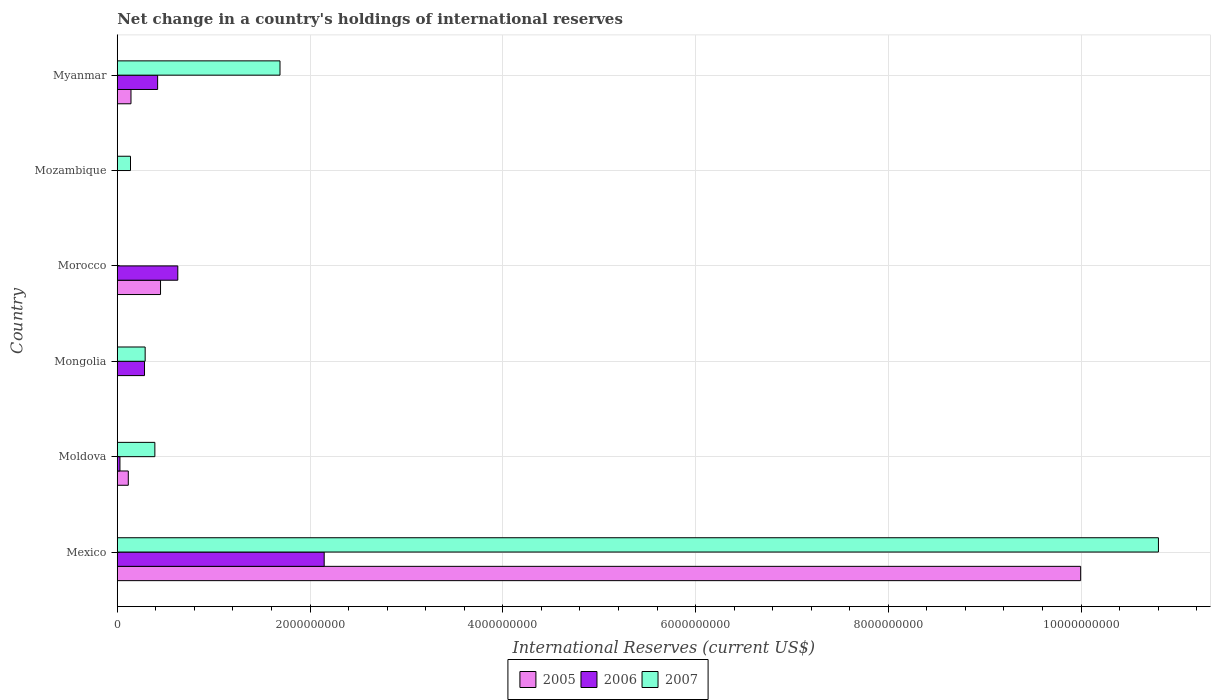Are the number of bars per tick equal to the number of legend labels?
Make the answer very short. No. Are the number of bars on each tick of the Y-axis equal?
Your response must be concise. No. How many bars are there on the 4th tick from the bottom?
Keep it short and to the point. 2. What is the label of the 5th group of bars from the top?
Provide a short and direct response. Moldova. In how many cases, is the number of bars for a given country not equal to the number of legend labels?
Offer a very short reply. 3. What is the international reserves in 2005 in Myanmar?
Provide a short and direct response. 1.42e+08. Across all countries, what is the maximum international reserves in 2007?
Keep it short and to the point. 1.08e+1. Across all countries, what is the minimum international reserves in 2005?
Ensure brevity in your answer.  0. What is the total international reserves in 2006 in the graph?
Give a very brief answer. 3.50e+09. What is the difference between the international reserves in 2006 in Mexico and that in Myanmar?
Offer a terse response. 1.73e+09. What is the difference between the international reserves in 2007 in Moldova and the international reserves in 2005 in Mongolia?
Your response must be concise. 3.90e+08. What is the average international reserves in 2006 per country?
Your response must be concise. 5.84e+08. What is the difference between the international reserves in 2007 and international reserves in 2005 in Moldova?
Your answer should be very brief. 2.76e+08. In how many countries, is the international reserves in 2006 greater than 7200000000 US$?
Give a very brief answer. 0. What is the ratio of the international reserves in 2007 in Moldova to that in Mongolia?
Your answer should be compact. 1.35. Is the difference between the international reserves in 2007 in Mexico and Myanmar greater than the difference between the international reserves in 2005 in Mexico and Myanmar?
Ensure brevity in your answer.  No. What is the difference between the highest and the second highest international reserves in 2006?
Provide a short and direct response. 1.52e+09. What is the difference between the highest and the lowest international reserves in 2007?
Ensure brevity in your answer.  1.08e+1. In how many countries, is the international reserves in 2005 greater than the average international reserves in 2005 taken over all countries?
Your answer should be very brief. 1. Are the values on the major ticks of X-axis written in scientific E-notation?
Provide a succinct answer. No. Where does the legend appear in the graph?
Your answer should be very brief. Bottom center. What is the title of the graph?
Keep it short and to the point. Net change in a country's holdings of international reserves. Does "2013" appear as one of the legend labels in the graph?
Keep it short and to the point. No. What is the label or title of the X-axis?
Your response must be concise. International Reserves (current US$). What is the label or title of the Y-axis?
Your response must be concise. Country. What is the International Reserves (current US$) in 2005 in Mexico?
Your response must be concise. 1.00e+1. What is the International Reserves (current US$) in 2006 in Mexico?
Your answer should be very brief. 2.15e+09. What is the International Reserves (current US$) of 2007 in Mexico?
Your answer should be compact. 1.08e+1. What is the International Reserves (current US$) of 2005 in Moldova?
Your answer should be compact. 1.14e+08. What is the International Reserves (current US$) in 2006 in Moldova?
Give a very brief answer. 2.75e+07. What is the International Reserves (current US$) of 2007 in Moldova?
Your response must be concise. 3.90e+08. What is the International Reserves (current US$) in 2006 in Mongolia?
Keep it short and to the point. 2.83e+08. What is the International Reserves (current US$) of 2007 in Mongolia?
Offer a very short reply. 2.89e+08. What is the International Reserves (current US$) of 2005 in Morocco?
Provide a short and direct response. 4.49e+08. What is the International Reserves (current US$) of 2006 in Morocco?
Your answer should be very brief. 6.28e+08. What is the International Reserves (current US$) of 2007 in Morocco?
Ensure brevity in your answer.  0. What is the International Reserves (current US$) in 2007 in Mozambique?
Your answer should be compact. 1.37e+08. What is the International Reserves (current US$) in 2005 in Myanmar?
Provide a succinct answer. 1.42e+08. What is the International Reserves (current US$) of 2006 in Myanmar?
Make the answer very short. 4.19e+08. What is the International Reserves (current US$) of 2007 in Myanmar?
Ensure brevity in your answer.  1.69e+09. Across all countries, what is the maximum International Reserves (current US$) of 2005?
Give a very brief answer. 1.00e+1. Across all countries, what is the maximum International Reserves (current US$) of 2006?
Make the answer very short. 2.15e+09. Across all countries, what is the maximum International Reserves (current US$) in 2007?
Keep it short and to the point. 1.08e+1. Across all countries, what is the minimum International Reserves (current US$) in 2005?
Make the answer very short. 0. What is the total International Reserves (current US$) of 2005 in the graph?
Your response must be concise. 1.07e+1. What is the total International Reserves (current US$) of 2006 in the graph?
Offer a terse response. 3.50e+09. What is the total International Reserves (current US$) of 2007 in the graph?
Your answer should be very brief. 1.33e+1. What is the difference between the International Reserves (current US$) of 2005 in Mexico and that in Moldova?
Offer a very short reply. 9.88e+09. What is the difference between the International Reserves (current US$) of 2006 in Mexico and that in Moldova?
Offer a terse response. 2.12e+09. What is the difference between the International Reserves (current US$) in 2007 in Mexico and that in Moldova?
Offer a very short reply. 1.04e+1. What is the difference between the International Reserves (current US$) of 2006 in Mexico and that in Mongolia?
Your response must be concise. 1.86e+09. What is the difference between the International Reserves (current US$) of 2007 in Mexico and that in Mongolia?
Provide a short and direct response. 1.05e+1. What is the difference between the International Reserves (current US$) in 2005 in Mexico and that in Morocco?
Ensure brevity in your answer.  9.55e+09. What is the difference between the International Reserves (current US$) in 2006 in Mexico and that in Morocco?
Offer a very short reply. 1.52e+09. What is the difference between the International Reserves (current US$) in 2007 in Mexico and that in Mozambique?
Your response must be concise. 1.07e+1. What is the difference between the International Reserves (current US$) in 2005 in Mexico and that in Myanmar?
Give a very brief answer. 9.85e+09. What is the difference between the International Reserves (current US$) of 2006 in Mexico and that in Myanmar?
Keep it short and to the point. 1.73e+09. What is the difference between the International Reserves (current US$) in 2007 in Mexico and that in Myanmar?
Offer a very short reply. 9.11e+09. What is the difference between the International Reserves (current US$) in 2006 in Moldova and that in Mongolia?
Provide a short and direct response. -2.55e+08. What is the difference between the International Reserves (current US$) of 2007 in Moldova and that in Mongolia?
Keep it short and to the point. 1.01e+08. What is the difference between the International Reserves (current US$) of 2005 in Moldova and that in Morocco?
Provide a short and direct response. -3.35e+08. What is the difference between the International Reserves (current US$) of 2006 in Moldova and that in Morocco?
Offer a terse response. -6.00e+08. What is the difference between the International Reserves (current US$) in 2007 in Moldova and that in Mozambique?
Ensure brevity in your answer.  2.53e+08. What is the difference between the International Reserves (current US$) in 2005 in Moldova and that in Myanmar?
Provide a succinct answer. -2.79e+07. What is the difference between the International Reserves (current US$) in 2006 in Moldova and that in Myanmar?
Offer a very short reply. -3.91e+08. What is the difference between the International Reserves (current US$) of 2007 in Moldova and that in Myanmar?
Offer a very short reply. -1.30e+09. What is the difference between the International Reserves (current US$) in 2006 in Mongolia and that in Morocco?
Your answer should be very brief. -3.45e+08. What is the difference between the International Reserves (current US$) in 2007 in Mongolia and that in Mozambique?
Make the answer very short. 1.52e+08. What is the difference between the International Reserves (current US$) in 2006 in Mongolia and that in Myanmar?
Make the answer very short. -1.36e+08. What is the difference between the International Reserves (current US$) in 2007 in Mongolia and that in Myanmar?
Provide a succinct answer. -1.40e+09. What is the difference between the International Reserves (current US$) of 2005 in Morocco and that in Myanmar?
Offer a very short reply. 3.07e+08. What is the difference between the International Reserves (current US$) of 2006 in Morocco and that in Myanmar?
Your answer should be compact. 2.09e+08. What is the difference between the International Reserves (current US$) in 2007 in Mozambique and that in Myanmar?
Offer a terse response. -1.55e+09. What is the difference between the International Reserves (current US$) in 2005 in Mexico and the International Reserves (current US$) in 2006 in Moldova?
Offer a terse response. 9.97e+09. What is the difference between the International Reserves (current US$) in 2005 in Mexico and the International Reserves (current US$) in 2007 in Moldova?
Give a very brief answer. 9.61e+09. What is the difference between the International Reserves (current US$) of 2006 in Mexico and the International Reserves (current US$) of 2007 in Moldova?
Your answer should be compact. 1.76e+09. What is the difference between the International Reserves (current US$) in 2005 in Mexico and the International Reserves (current US$) in 2006 in Mongolia?
Provide a succinct answer. 9.71e+09. What is the difference between the International Reserves (current US$) of 2005 in Mexico and the International Reserves (current US$) of 2007 in Mongolia?
Your answer should be compact. 9.71e+09. What is the difference between the International Reserves (current US$) in 2006 in Mexico and the International Reserves (current US$) in 2007 in Mongolia?
Keep it short and to the point. 1.86e+09. What is the difference between the International Reserves (current US$) in 2005 in Mexico and the International Reserves (current US$) in 2006 in Morocco?
Keep it short and to the point. 9.37e+09. What is the difference between the International Reserves (current US$) in 2005 in Mexico and the International Reserves (current US$) in 2007 in Mozambique?
Your answer should be very brief. 9.86e+09. What is the difference between the International Reserves (current US$) in 2006 in Mexico and the International Reserves (current US$) in 2007 in Mozambique?
Your answer should be very brief. 2.01e+09. What is the difference between the International Reserves (current US$) in 2005 in Mexico and the International Reserves (current US$) in 2006 in Myanmar?
Give a very brief answer. 9.58e+09. What is the difference between the International Reserves (current US$) of 2005 in Mexico and the International Reserves (current US$) of 2007 in Myanmar?
Your response must be concise. 8.31e+09. What is the difference between the International Reserves (current US$) of 2006 in Mexico and the International Reserves (current US$) of 2007 in Myanmar?
Make the answer very short. 4.58e+08. What is the difference between the International Reserves (current US$) of 2005 in Moldova and the International Reserves (current US$) of 2006 in Mongolia?
Give a very brief answer. -1.68e+08. What is the difference between the International Reserves (current US$) in 2005 in Moldova and the International Reserves (current US$) in 2007 in Mongolia?
Your answer should be very brief. -1.75e+08. What is the difference between the International Reserves (current US$) of 2006 in Moldova and the International Reserves (current US$) of 2007 in Mongolia?
Ensure brevity in your answer.  -2.62e+08. What is the difference between the International Reserves (current US$) of 2005 in Moldova and the International Reserves (current US$) of 2006 in Morocco?
Provide a succinct answer. -5.14e+08. What is the difference between the International Reserves (current US$) in 2005 in Moldova and the International Reserves (current US$) in 2007 in Mozambique?
Your answer should be compact. -2.29e+07. What is the difference between the International Reserves (current US$) of 2006 in Moldova and the International Reserves (current US$) of 2007 in Mozambique?
Your answer should be very brief. -1.10e+08. What is the difference between the International Reserves (current US$) in 2005 in Moldova and the International Reserves (current US$) in 2006 in Myanmar?
Offer a very short reply. -3.04e+08. What is the difference between the International Reserves (current US$) of 2005 in Moldova and the International Reserves (current US$) of 2007 in Myanmar?
Your response must be concise. -1.57e+09. What is the difference between the International Reserves (current US$) in 2006 in Moldova and the International Reserves (current US$) in 2007 in Myanmar?
Offer a very short reply. -1.66e+09. What is the difference between the International Reserves (current US$) of 2006 in Mongolia and the International Reserves (current US$) of 2007 in Mozambique?
Offer a very short reply. 1.45e+08. What is the difference between the International Reserves (current US$) in 2006 in Mongolia and the International Reserves (current US$) in 2007 in Myanmar?
Provide a short and direct response. -1.41e+09. What is the difference between the International Reserves (current US$) of 2005 in Morocco and the International Reserves (current US$) of 2007 in Mozambique?
Keep it short and to the point. 3.12e+08. What is the difference between the International Reserves (current US$) in 2006 in Morocco and the International Reserves (current US$) in 2007 in Mozambique?
Keep it short and to the point. 4.91e+08. What is the difference between the International Reserves (current US$) of 2005 in Morocco and the International Reserves (current US$) of 2006 in Myanmar?
Provide a short and direct response. 3.01e+07. What is the difference between the International Reserves (current US$) in 2005 in Morocco and the International Reserves (current US$) in 2007 in Myanmar?
Offer a terse response. -1.24e+09. What is the difference between the International Reserves (current US$) of 2006 in Morocco and the International Reserves (current US$) of 2007 in Myanmar?
Your response must be concise. -1.06e+09. What is the average International Reserves (current US$) of 2005 per country?
Offer a terse response. 1.78e+09. What is the average International Reserves (current US$) in 2006 per country?
Your response must be concise. 5.84e+08. What is the average International Reserves (current US$) of 2007 per country?
Your answer should be very brief. 2.22e+09. What is the difference between the International Reserves (current US$) in 2005 and International Reserves (current US$) in 2006 in Mexico?
Ensure brevity in your answer.  7.85e+09. What is the difference between the International Reserves (current US$) of 2005 and International Reserves (current US$) of 2007 in Mexico?
Provide a short and direct response. -8.07e+08. What is the difference between the International Reserves (current US$) of 2006 and International Reserves (current US$) of 2007 in Mexico?
Your answer should be compact. -8.66e+09. What is the difference between the International Reserves (current US$) of 2005 and International Reserves (current US$) of 2006 in Moldova?
Your answer should be very brief. 8.67e+07. What is the difference between the International Reserves (current US$) of 2005 and International Reserves (current US$) of 2007 in Moldova?
Make the answer very short. -2.76e+08. What is the difference between the International Reserves (current US$) of 2006 and International Reserves (current US$) of 2007 in Moldova?
Your response must be concise. -3.62e+08. What is the difference between the International Reserves (current US$) of 2006 and International Reserves (current US$) of 2007 in Mongolia?
Your response must be concise. -6.62e+06. What is the difference between the International Reserves (current US$) of 2005 and International Reserves (current US$) of 2006 in Morocco?
Offer a terse response. -1.79e+08. What is the difference between the International Reserves (current US$) in 2005 and International Reserves (current US$) in 2006 in Myanmar?
Your answer should be compact. -2.77e+08. What is the difference between the International Reserves (current US$) of 2005 and International Reserves (current US$) of 2007 in Myanmar?
Offer a terse response. -1.55e+09. What is the difference between the International Reserves (current US$) in 2006 and International Reserves (current US$) in 2007 in Myanmar?
Ensure brevity in your answer.  -1.27e+09. What is the ratio of the International Reserves (current US$) of 2005 in Mexico to that in Moldova?
Your answer should be compact. 87.52. What is the ratio of the International Reserves (current US$) in 2006 in Mexico to that in Moldova?
Ensure brevity in your answer.  78.11. What is the ratio of the International Reserves (current US$) in 2007 in Mexico to that in Moldova?
Keep it short and to the point. 27.7. What is the ratio of the International Reserves (current US$) of 2006 in Mexico to that in Mongolia?
Make the answer very short. 7.6. What is the ratio of the International Reserves (current US$) in 2007 in Mexico to that in Mongolia?
Your answer should be very brief. 37.36. What is the ratio of the International Reserves (current US$) in 2005 in Mexico to that in Morocco?
Give a very brief answer. 22.28. What is the ratio of the International Reserves (current US$) of 2006 in Mexico to that in Morocco?
Make the answer very short. 3.42. What is the ratio of the International Reserves (current US$) of 2007 in Mexico to that in Mozambique?
Your answer should be very brief. 78.79. What is the ratio of the International Reserves (current US$) in 2005 in Mexico to that in Myanmar?
Give a very brief answer. 70.34. What is the ratio of the International Reserves (current US$) of 2006 in Mexico to that in Myanmar?
Give a very brief answer. 5.13. What is the ratio of the International Reserves (current US$) of 2007 in Mexico to that in Myanmar?
Provide a short and direct response. 6.4. What is the ratio of the International Reserves (current US$) in 2006 in Moldova to that in Mongolia?
Offer a very short reply. 0.1. What is the ratio of the International Reserves (current US$) of 2007 in Moldova to that in Mongolia?
Provide a short and direct response. 1.35. What is the ratio of the International Reserves (current US$) of 2005 in Moldova to that in Morocco?
Provide a succinct answer. 0.25. What is the ratio of the International Reserves (current US$) in 2006 in Moldova to that in Morocco?
Your response must be concise. 0.04. What is the ratio of the International Reserves (current US$) of 2007 in Moldova to that in Mozambique?
Offer a very short reply. 2.84. What is the ratio of the International Reserves (current US$) in 2005 in Moldova to that in Myanmar?
Give a very brief answer. 0.8. What is the ratio of the International Reserves (current US$) in 2006 in Moldova to that in Myanmar?
Make the answer very short. 0.07. What is the ratio of the International Reserves (current US$) of 2007 in Moldova to that in Myanmar?
Keep it short and to the point. 0.23. What is the ratio of the International Reserves (current US$) in 2006 in Mongolia to that in Morocco?
Your answer should be compact. 0.45. What is the ratio of the International Reserves (current US$) in 2007 in Mongolia to that in Mozambique?
Offer a very short reply. 2.11. What is the ratio of the International Reserves (current US$) of 2006 in Mongolia to that in Myanmar?
Your answer should be very brief. 0.67. What is the ratio of the International Reserves (current US$) of 2007 in Mongolia to that in Myanmar?
Ensure brevity in your answer.  0.17. What is the ratio of the International Reserves (current US$) of 2005 in Morocco to that in Myanmar?
Provide a short and direct response. 3.16. What is the ratio of the International Reserves (current US$) of 2006 in Morocco to that in Myanmar?
Offer a very short reply. 1.5. What is the ratio of the International Reserves (current US$) in 2007 in Mozambique to that in Myanmar?
Your answer should be compact. 0.08. What is the difference between the highest and the second highest International Reserves (current US$) in 2005?
Give a very brief answer. 9.55e+09. What is the difference between the highest and the second highest International Reserves (current US$) in 2006?
Make the answer very short. 1.52e+09. What is the difference between the highest and the second highest International Reserves (current US$) of 2007?
Keep it short and to the point. 9.11e+09. What is the difference between the highest and the lowest International Reserves (current US$) of 2005?
Make the answer very short. 1.00e+1. What is the difference between the highest and the lowest International Reserves (current US$) of 2006?
Give a very brief answer. 2.15e+09. What is the difference between the highest and the lowest International Reserves (current US$) of 2007?
Offer a very short reply. 1.08e+1. 